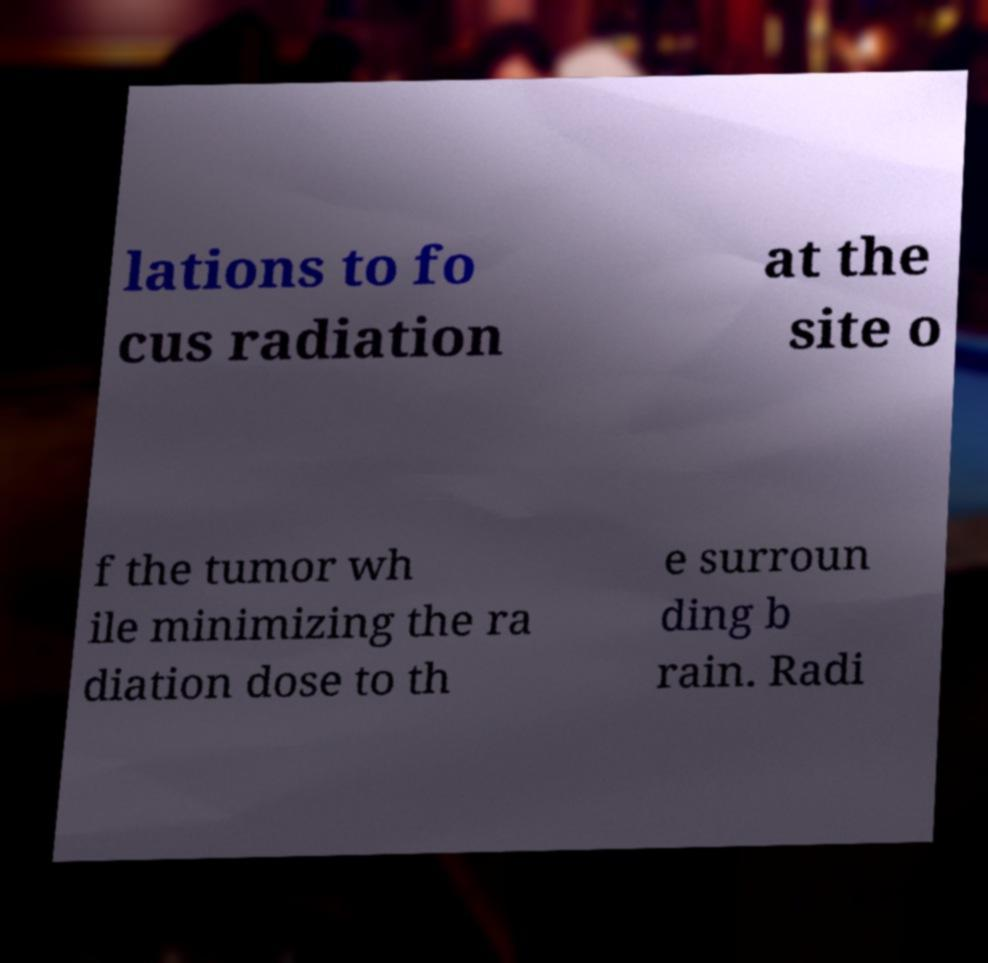Could you assist in decoding the text presented in this image and type it out clearly? lations to fo cus radiation at the site o f the tumor wh ile minimizing the ra diation dose to th e surroun ding b rain. Radi 